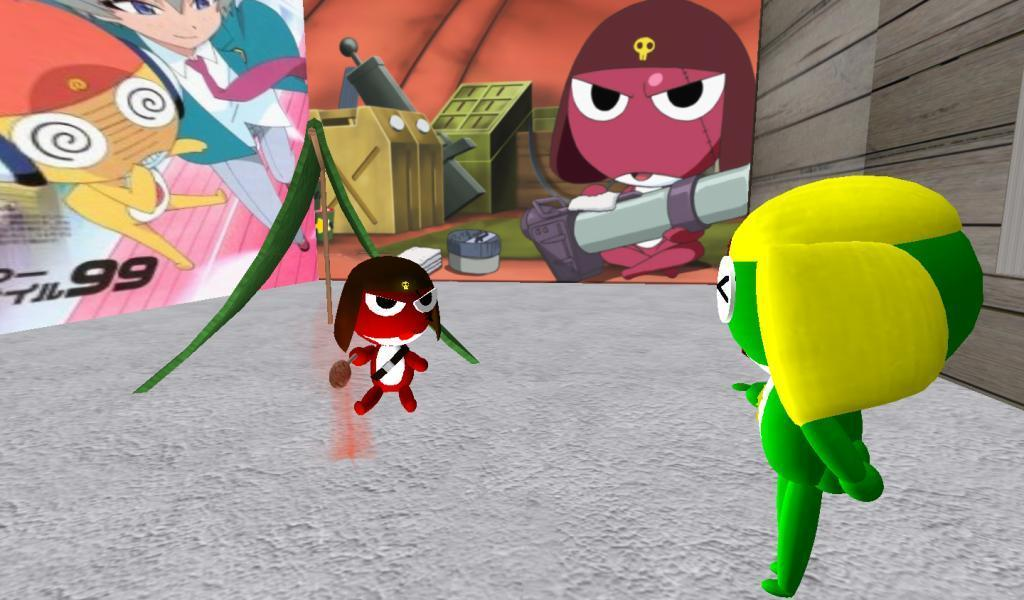What type of media is the image? The image is an animation. What objects can be seen in the image? There are toys in the image. What is visible in the background of the image? There are boards in the background of the image. What is depicted on the boards? There are pictures of cartons and boxes on the boards. Can you see an owl perched on the icicle in the image? There is no owl or icicle present in the image. 